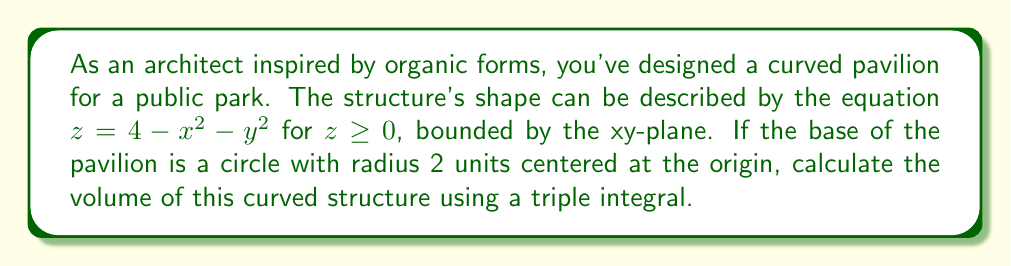What is the answer to this math problem? To solve this problem, we'll use cylindrical coordinates and set up a triple integral. Here's the step-by-step process:

1) First, let's visualize the structure:

[asy]
import graph3;
size(200);
currentprojection=perspective(6,3,2);
triple f(pair t) {return (t.x*cos(t.y),t.x*sin(t.y),4-t.x^2);}
surface s=surface(f,(0,0),(2,2pi),8,16,Spline);
draw(s,paleblue);
draw(circle((0,0,0),2),blue);
draw((-2,0,0)--(2,0,0),arrow=Arrow3);
draw((0,-2,0)--(0,2,0),arrow=Arrow3);
draw((0,0,0)--(0,0,4),arrow=Arrow3);
label("x",(-2,0,0),W);
label("y",(0,-2,0),S);
label("z",(0,0,4),N);
[/asy]

2) In cylindrical coordinates, we have:
   $x = r \cos(\theta)$
   $y = r \sin(\theta)$
   $z = z$

3) The equation of the surface becomes:
   $z = 4 - r^2$

4) The volume is bounded by:
   $0 \leq r \leq 2$ (radius of the base)
   $0 \leq \theta \leq 2\pi$ (full circle)
   $0 \leq z \leq 4 - r^2$ (from the xy-plane to the surface)

5) The triple integral for the volume is:

   $$V = \int_0^{2\pi} \int_0^2 \int_0^{4-r^2} r \, dz \, dr \, d\theta$$

6) Let's solve the integral:
   
   $$V = \int_0^{2\pi} \int_0^2 r(4-r^2) \, dr \, d\theta$$
   
   $$= \int_0^{2\pi} \left[ 2r^2 - \frac{r^4}{4} \right]_0^2 \, d\theta$$
   
   $$= \int_0^{2\pi} \left( 8 - 1 \right) \, d\theta$$
   
   $$= 7 \int_0^{2\pi} \, d\theta$$
   
   $$= 7 \cdot 2\pi$$
   
   $$= 14\pi$$

Thus, the volume of the curved pavilion is $14\pi$ cubic units.
Answer: $14\pi$ cubic units 